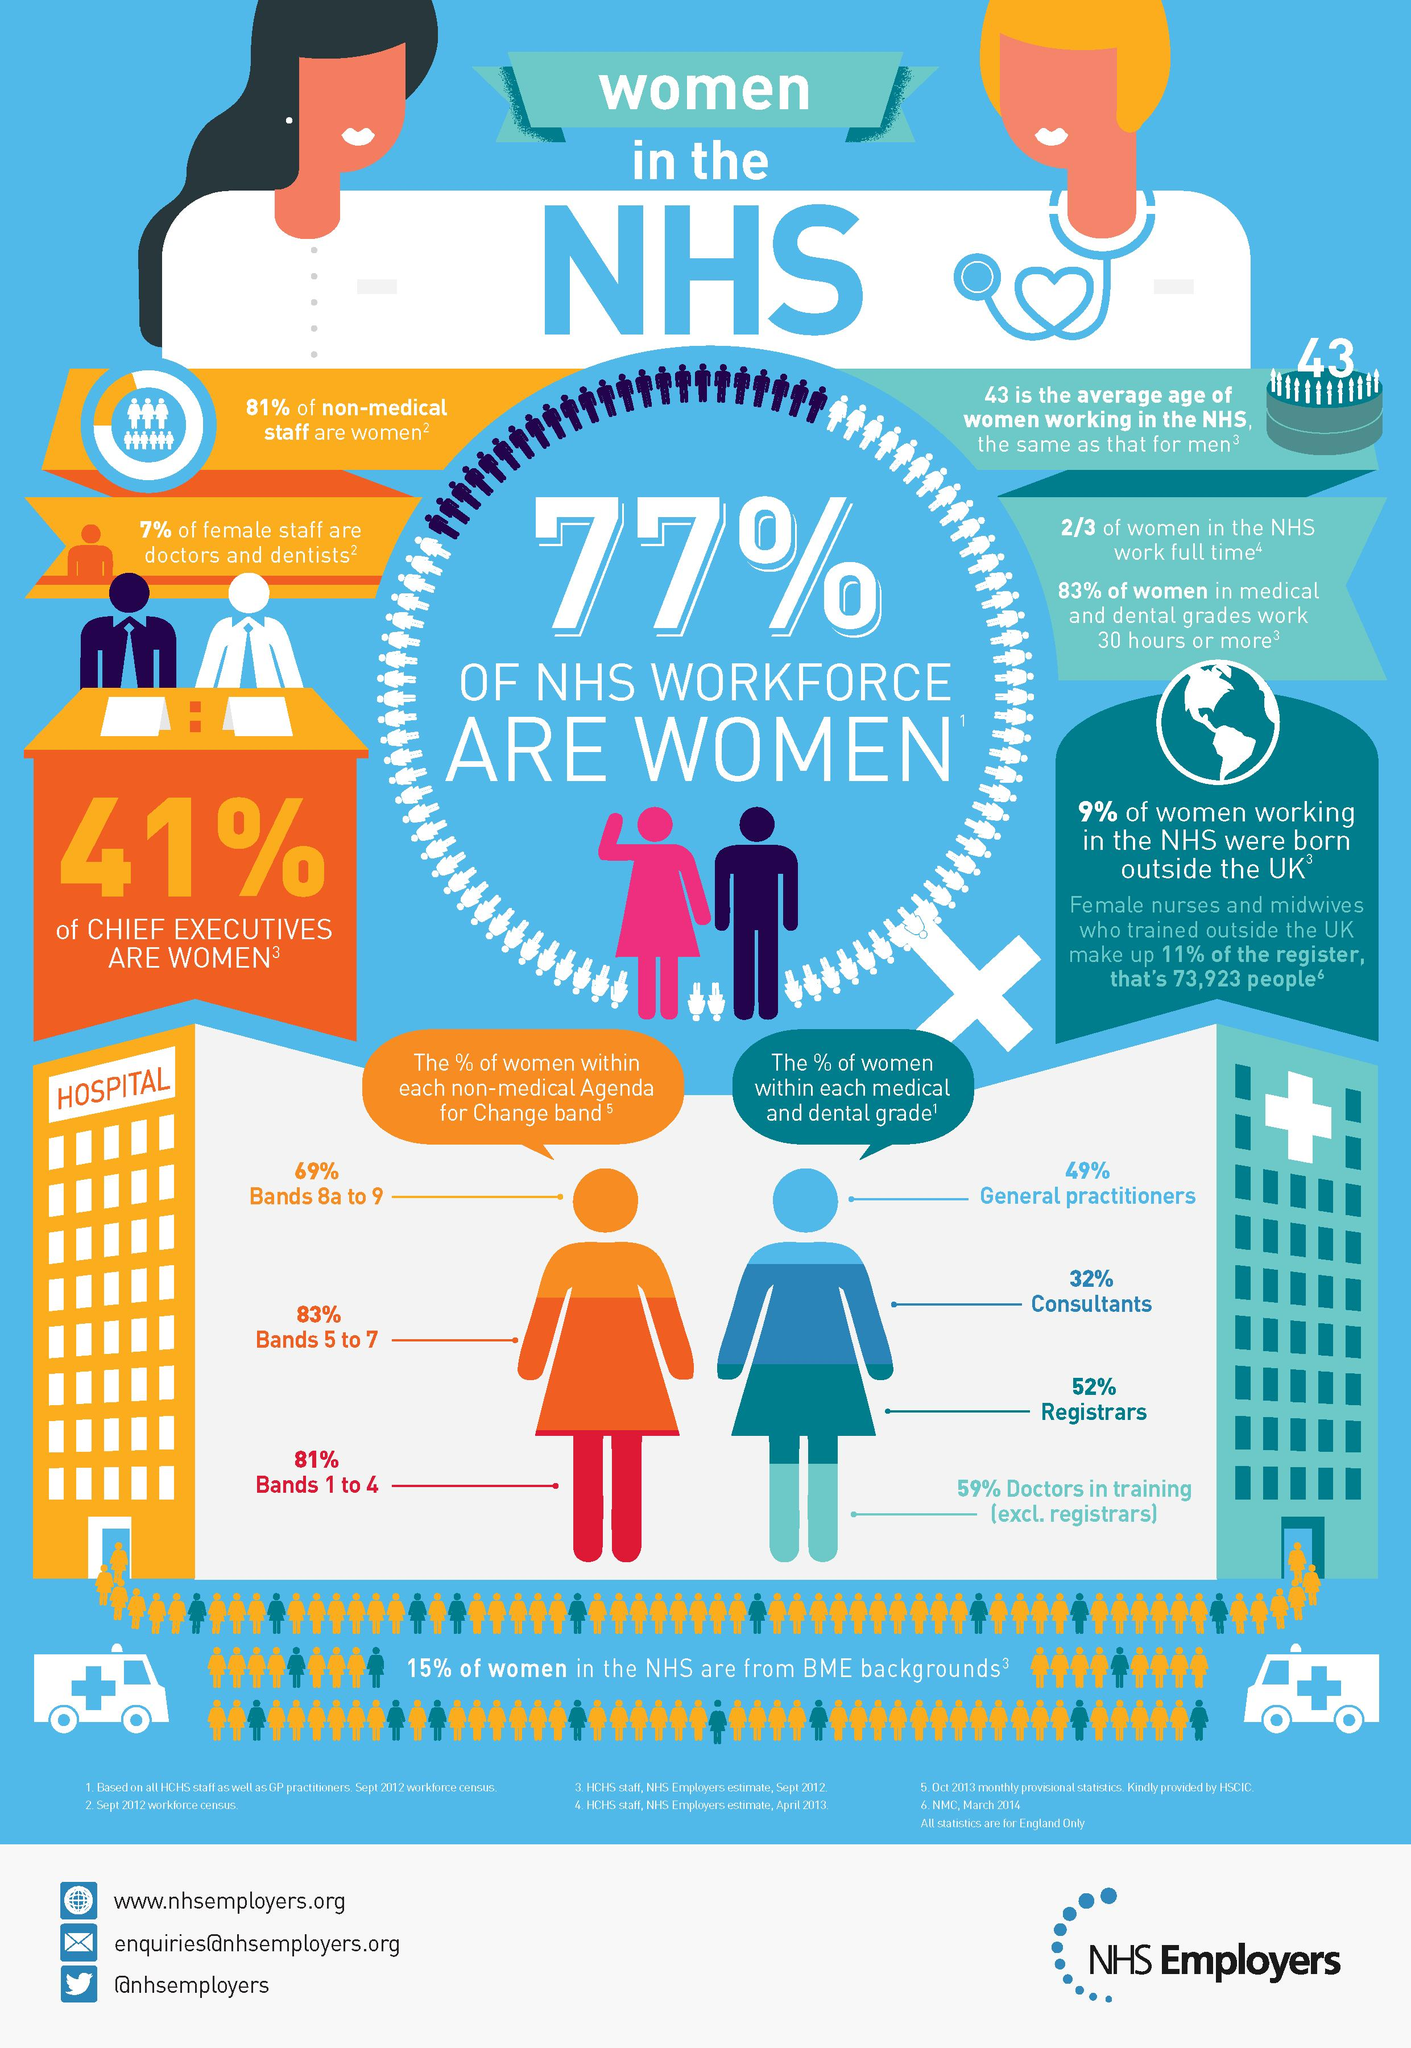Highlight a few significant elements in this photo. According to data, 66.67% of women working in the NHS hold full-time positions. The average age of men working in the National Health Service (NHS) is 43. 